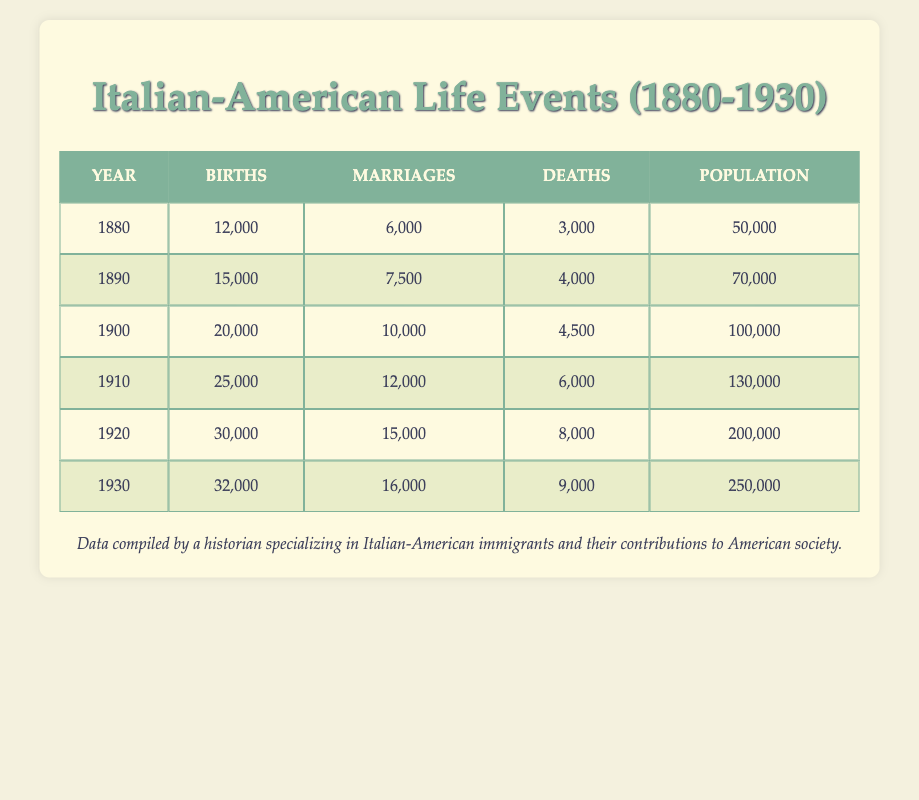What was the total number of births from 1880 to 1930? To find the total number of births, we add the births for each year: 12000 + 15000 + 20000 + 25000 + 30000 + 32000 = 134000.
Answer: 134000 In which year were the highest number of marriages recorded? Looking at the table, the highest number of marriages is in the year 1930, with 16000 marriages.
Answer: 1930 What was the average number of deaths per year from 1880 to 1930? To calculate the average number of deaths, we first sum the deaths: 3000 + 4000 + 4500 + 6000 + 8000 + 9000 = 34000. Then, since there are 6 years in the interval, the average is 34000 / 6 = 5666.67.
Answer: 5666.67 Was the population of Italian-Americans greater in 1920 or in 1930? The population in 1920 was 200000 and in 1930 it was 250000. Therefore, the population was greater in 1930.
Answer: 1930 What percentage of the population were births in 1900? In 1900, there were 20000 births and a population of 100000. The percentage is (20000 / 100000) * 100 = 20%.
Answer: 20% Calculate the difference in the number of marriages between 1880 and 1930. In 1880, there were 6000 marriages and in 1930 there were 16000. The difference is 16000 - 6000 = 10000.
Answer: 10000 What proportion of the total population were deaths in 1910? In 1910, there were 6000 deaths out of a population of 130000. The proportion is 6000 / 130000 = 0.04615, or approximately 4.62%.
Answer: 4.62% In which decade did the Italian-American population grow the most? By examining the population growth decade by decade, from 1880 to 1890 the increase was 20000 (70000 - 50000), from 1890 to 1900 it was 30000 (100000 - 70000), from 1900 to 1910 it was 30000, from 1910 to 1920 it was 70000 (200000 - 130000), and from 1920 to 1930 it was 50000 (250000 - 200000). The decade from 1910 to 1920 had the largest increase of 70000.
Answer: 1910 to 1920 Did the number of births increase every decade between 1880 and 1930? Looking at the births in the table, they are as follows: 12000, 15000, 20000, 25000, 30000, and 32000. Since all these values are increasing, yes, the number of births did increase every decade.
Answer: Yes 